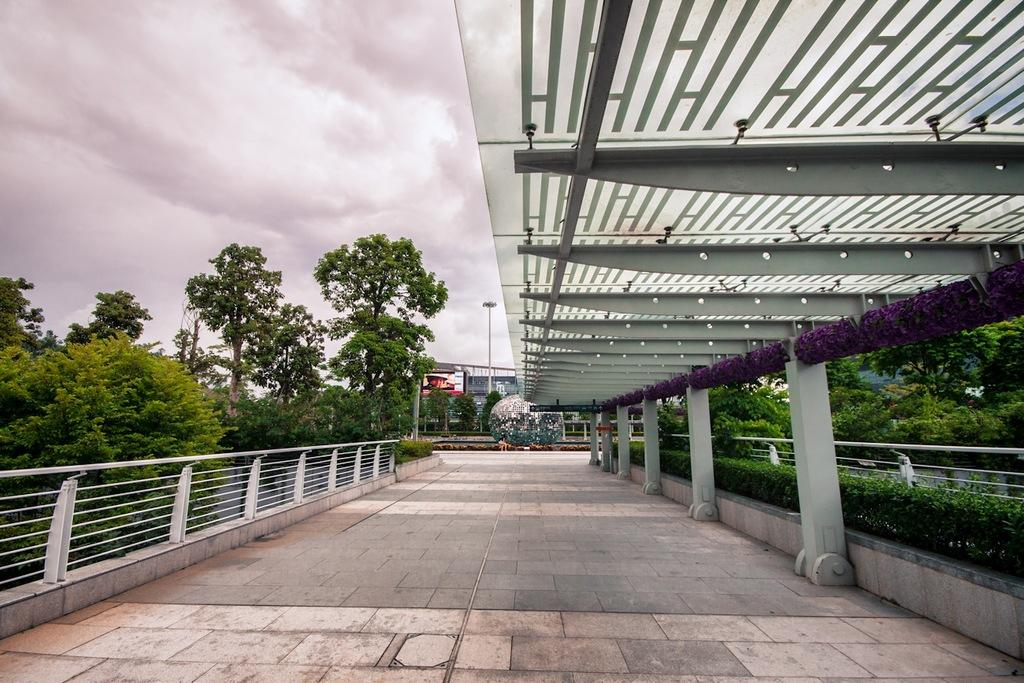What type of vegetation can be seen in the image? There are trees in the image. What type of structures are present in the image? There are buildings in the image. What object can be seen standing upright in the image? There is a pole in the image. What type of landscaping feature is present in the image? There is a hedge in the image. What type of surface is visible at the bottom of the image? Paving blocks are visible at the bottom of the image. What type of cat can be seen solving arithmetic problems in the image? There is no cat or arithmetic problems present in the image. How many dolls are sitting on the hedge in the image? There are no dolls present in the image. 